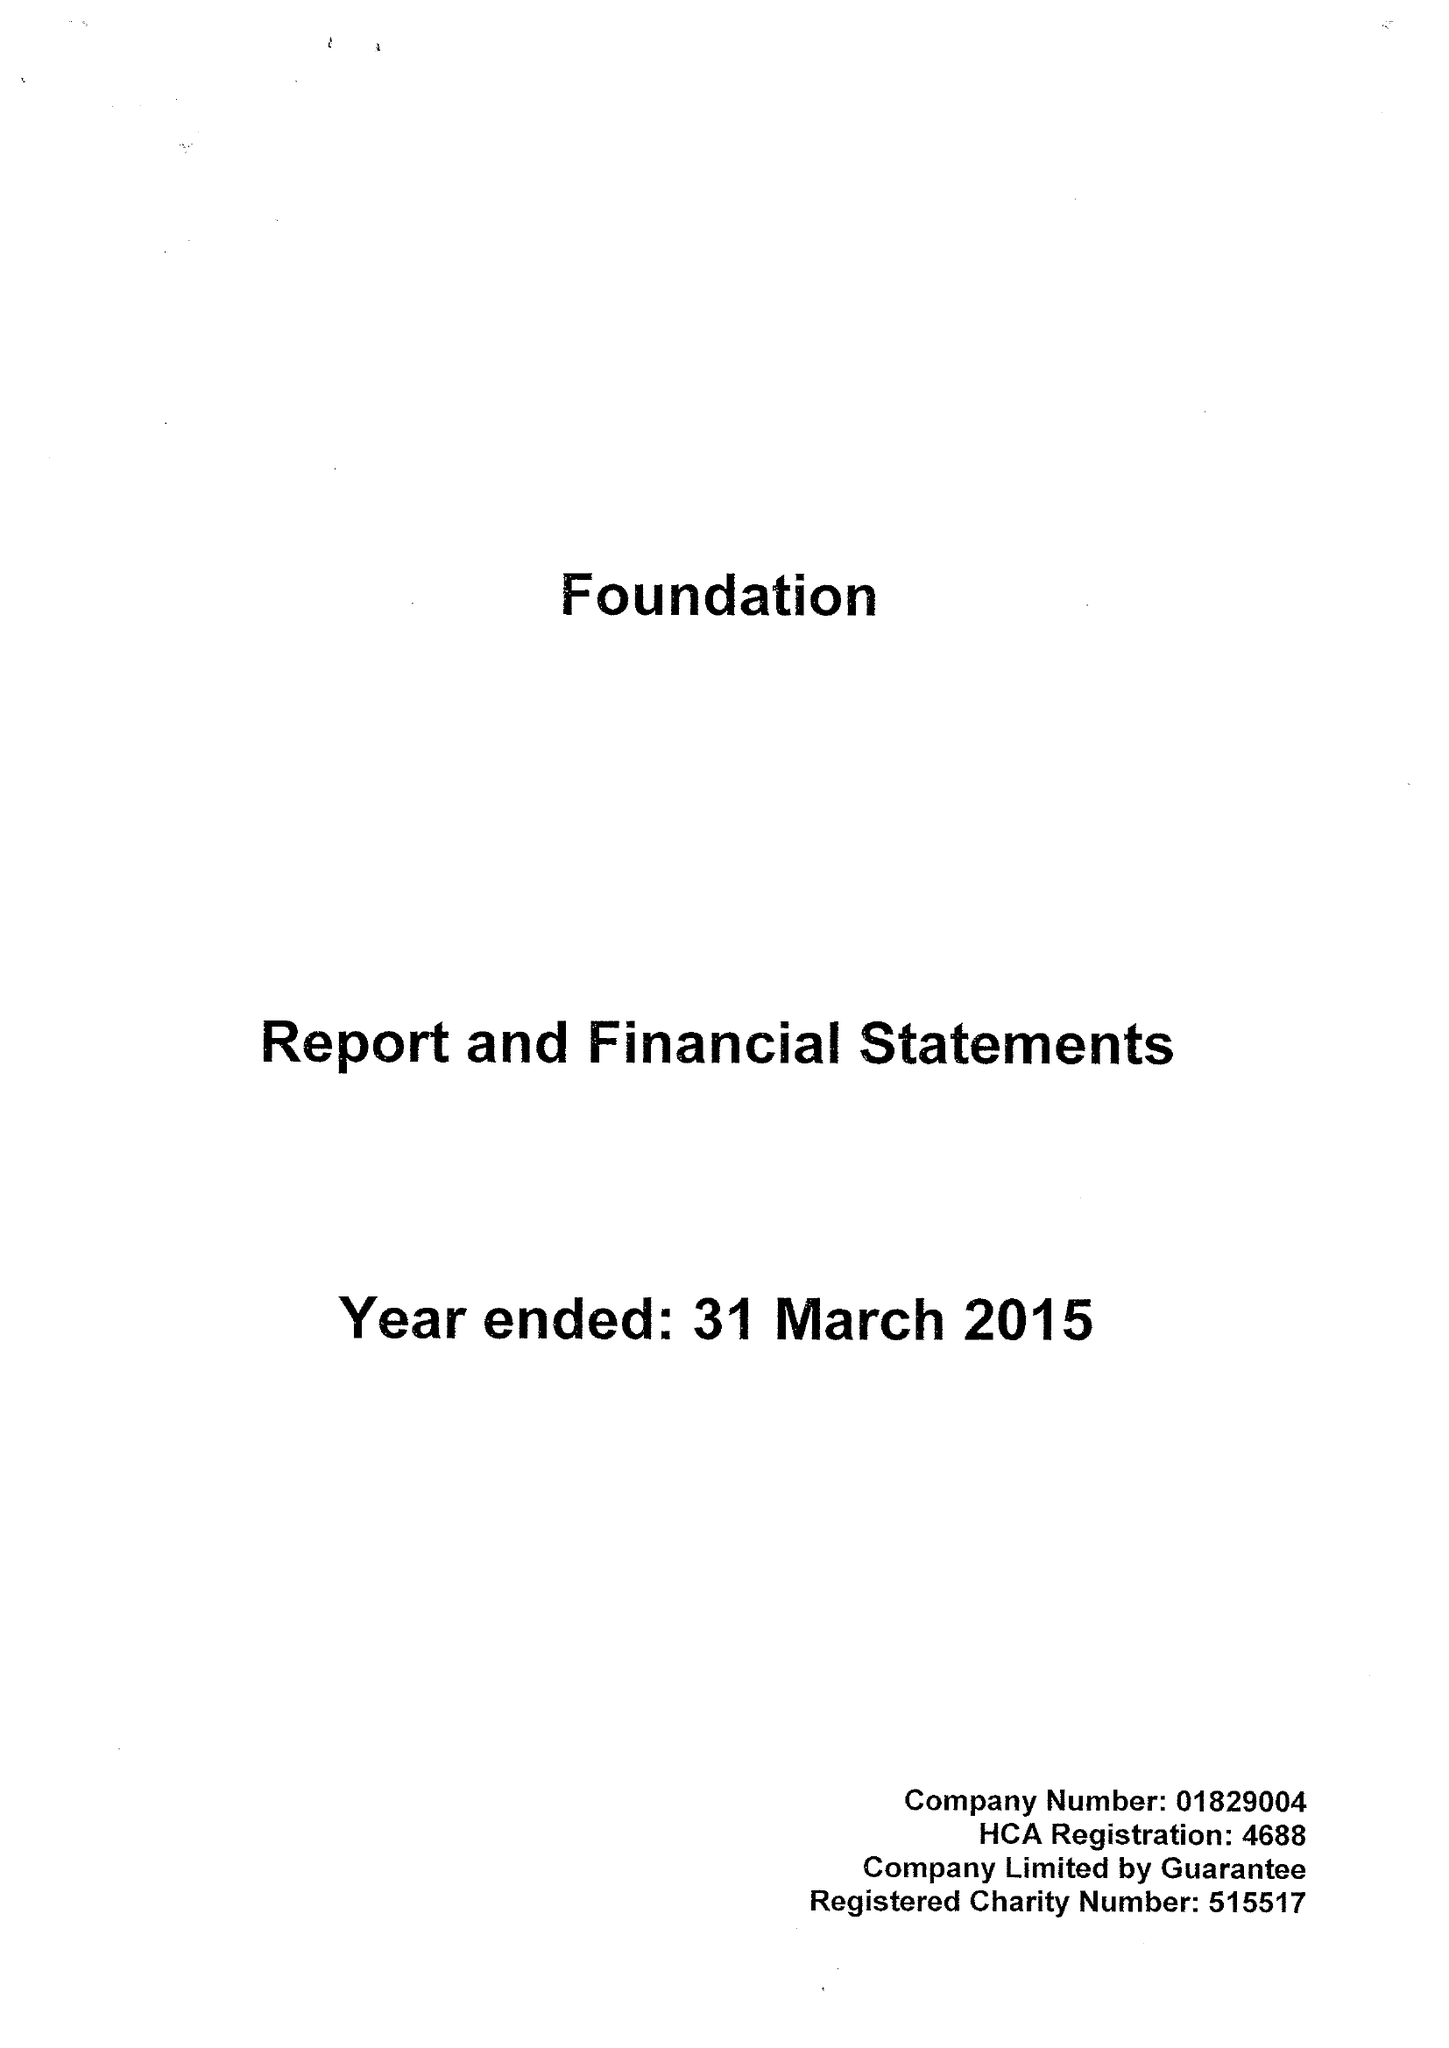What is the value for the address__post_town?
Answer the question using a single word or phrase. LEEDS 